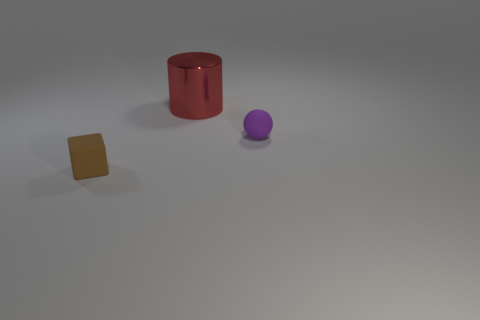Add 3 large red metal objects. How many objects exist? 6 Subtract all blocks. How many objects are left? 2 Add 2 red shiny cylinders. How many red shiny cylinders are left? 3 Add 3 small brown things. How many small brown things exist? 4 Subtract 0 red cubes. How many objects are left? 3 Subtract all small brown rubber blocks. Subtract all big red shiny things. How many objects are left? 1 